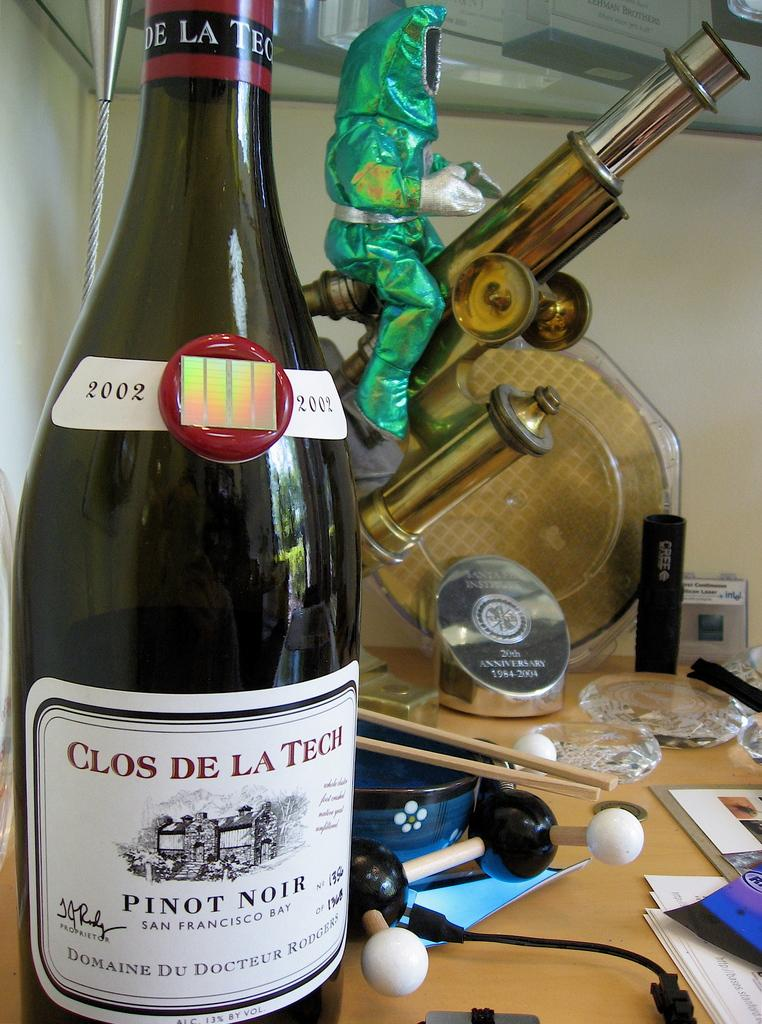Provide a one-sentence caption for the provided image. A bottle of Clos De La Tech pinot noir wine sitting on a cuttered table. 